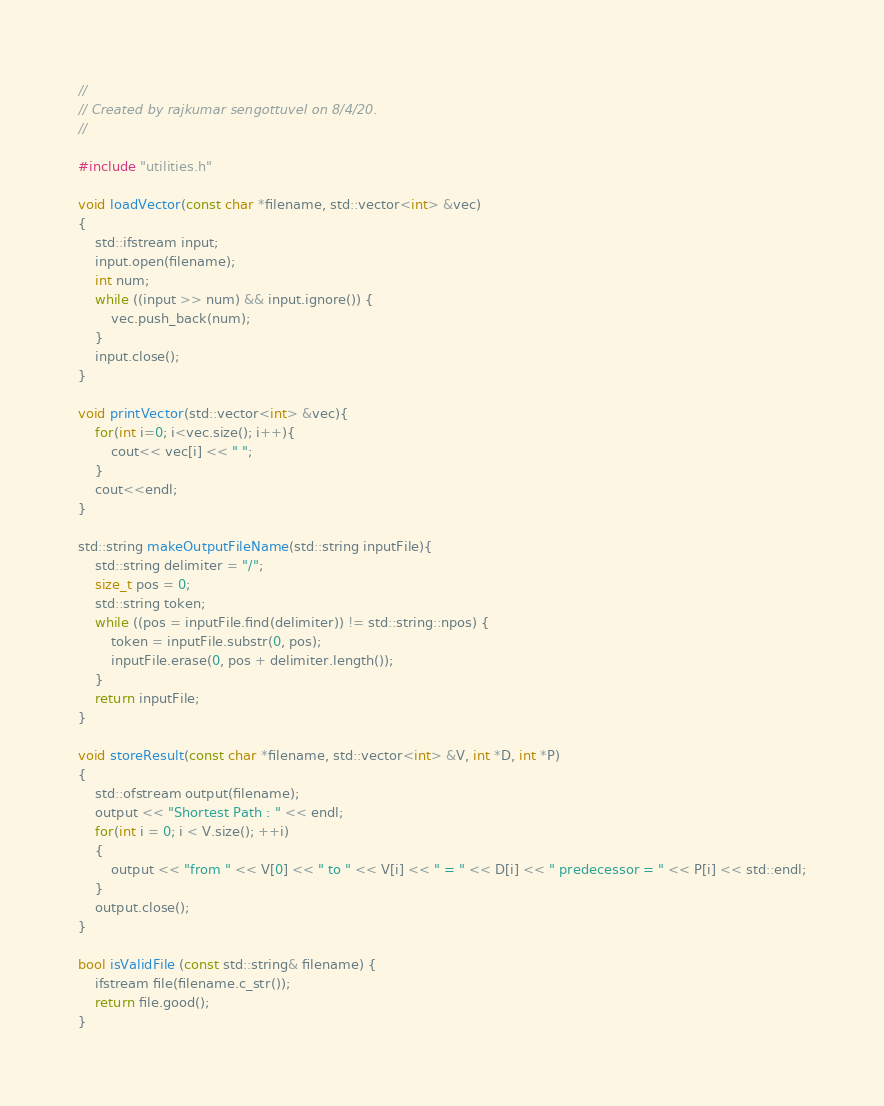<code> <loc_0><loc_0><loc_500><loc_500><_C++_>//
// Created by rajkumar sengottuvel on 8/4/20.
//

#include "utilities.h"

void loadVector(const char *filename, std::vector<int> &vec)
{
    std::ifstream input;
    input.open(filename);
    int num;
    while ((input >> num) && input.ignore()) {
        vec.push_back(num);
    }
    input.close();
}

void printVector(std::vector<int> &vec){
    for(int i=0; i<vec.size(); i++){
        cout<< vec[i] << " ";
    }
    cout<<endl;
}

std::string makeOutputFileName(std::string inputFile){
    std::string delimiter = "/";
    size_t pos = 0;
    std::string token;
    while ((pos = inputFile.find(delimiter)) != std::string::npos) {
        token = inputFile.substr(0, pos);
        inputFile.erase(0, pos + delimiter.length());
    }
    return inputFile;
}

void storeResult(const char *filename, std::vector<int> &V, int *D, int *P)
{
    std::ofstream output(filename);
    output << "Shortest Path : " << endl;
    for(int i = 0; i < V.size(); ++i)
    {
        output << "from " << V[0] << " to " << V[i] << " = " << D[i] << " predecessor = " << P[i] << std::endl;
    }
    output.close();
}

bool isValidFile (const std::string& filename) {
    ifstream file(filename.c_str());
    return file.good();
}</code> 